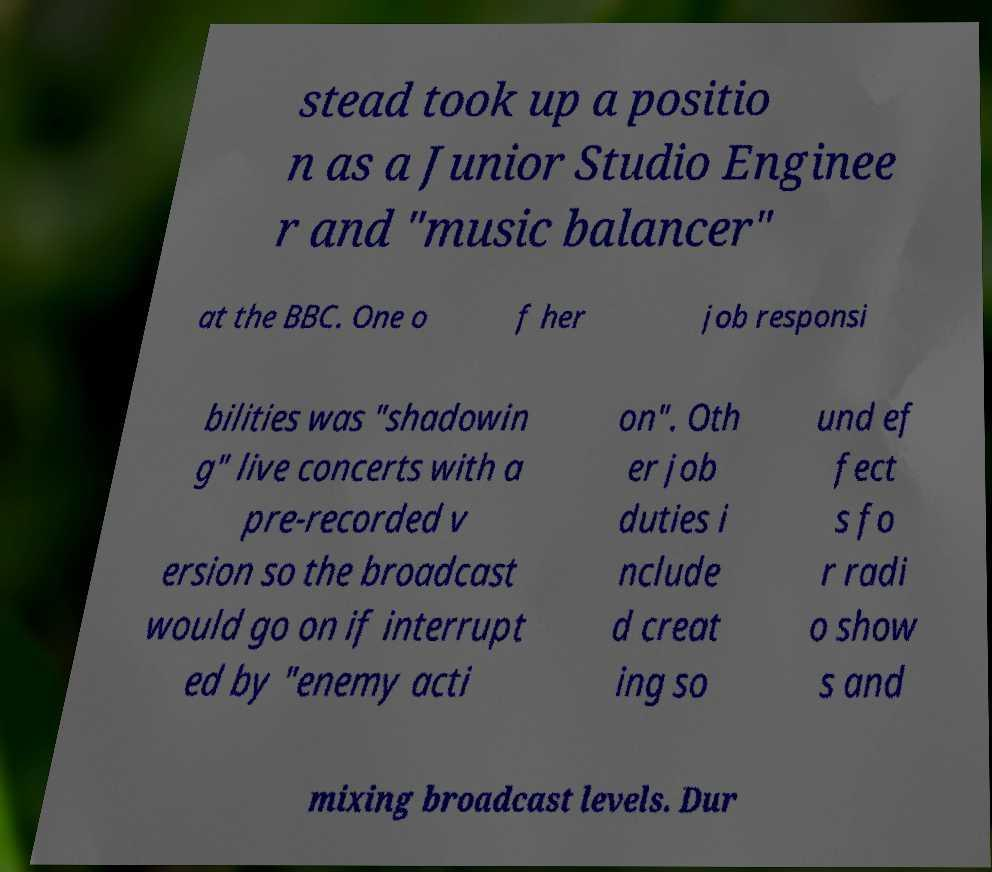What messages or text are displayed in this image? I need them in a readable, typed format. stead took up a positio n as a Junior Studio Enginee r and "music balancer" at the BBC. One o f her job responsi bilities was "shadowin g" live concerts with a pre-recorded v ersion so the broadcast would go on if interrupt ed by "enemy acti on". Oth er job duties i nclude d creat ing so und ef fect s fo r radi o show s and mixing broadcast levels. Dur 